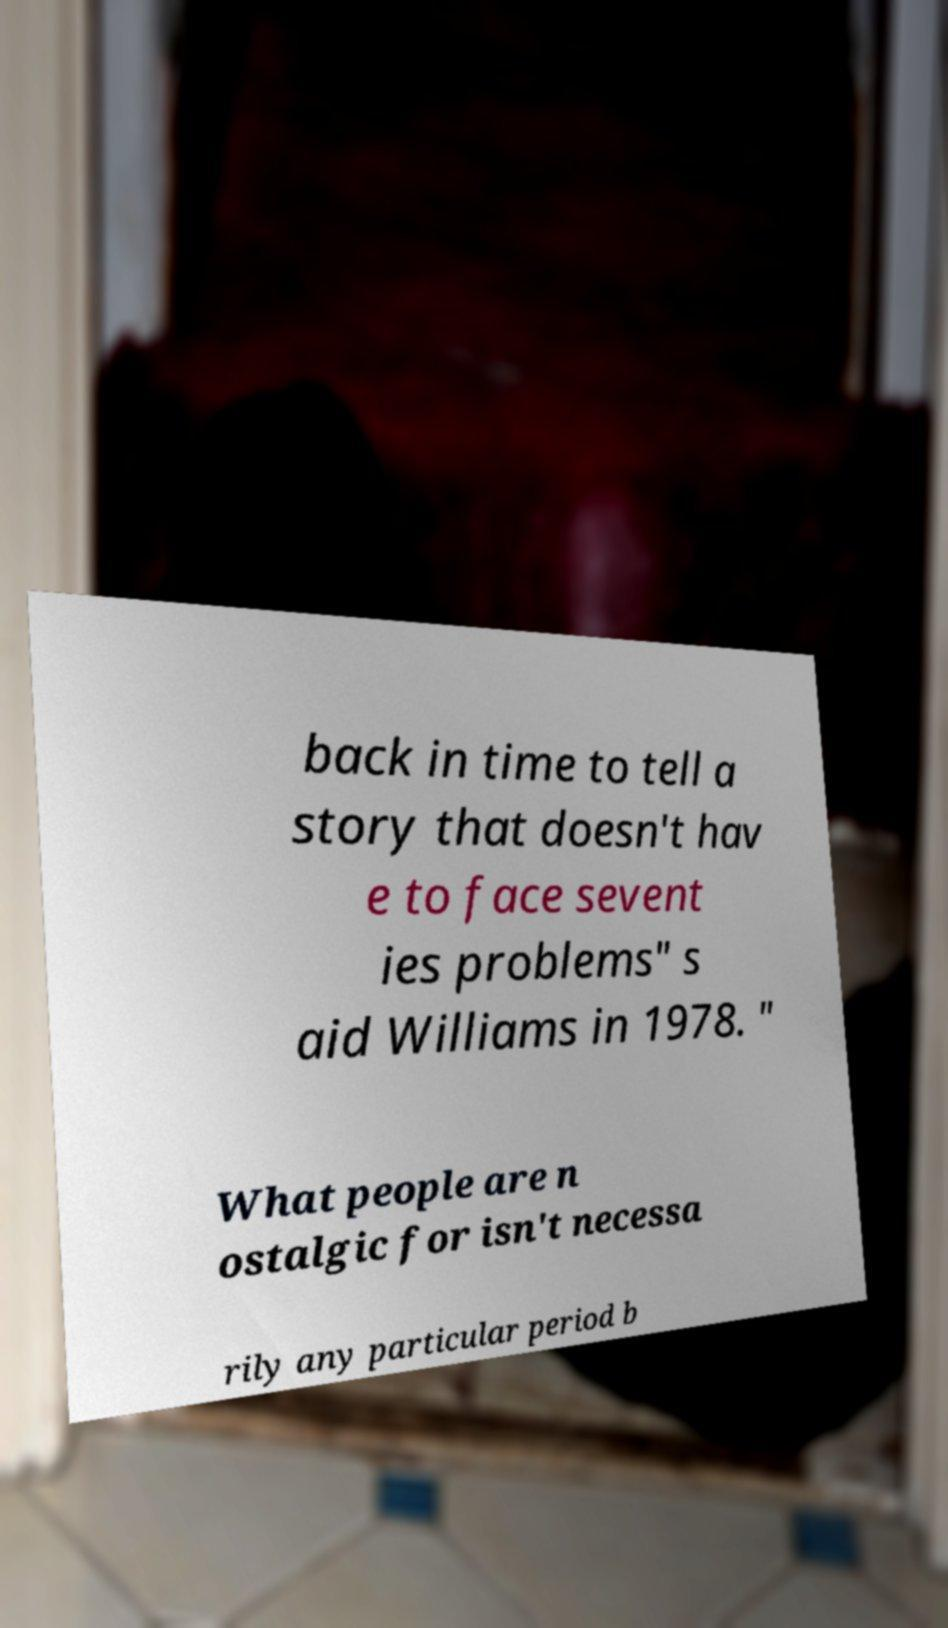Can you accurately transcribe the text from the provided image for me? back in time to tell a story that doesn't hav e to face sevent ies problems" s aid Williams in 1978. " What people are n ostalgic for isn't necessa rily any particular period b 